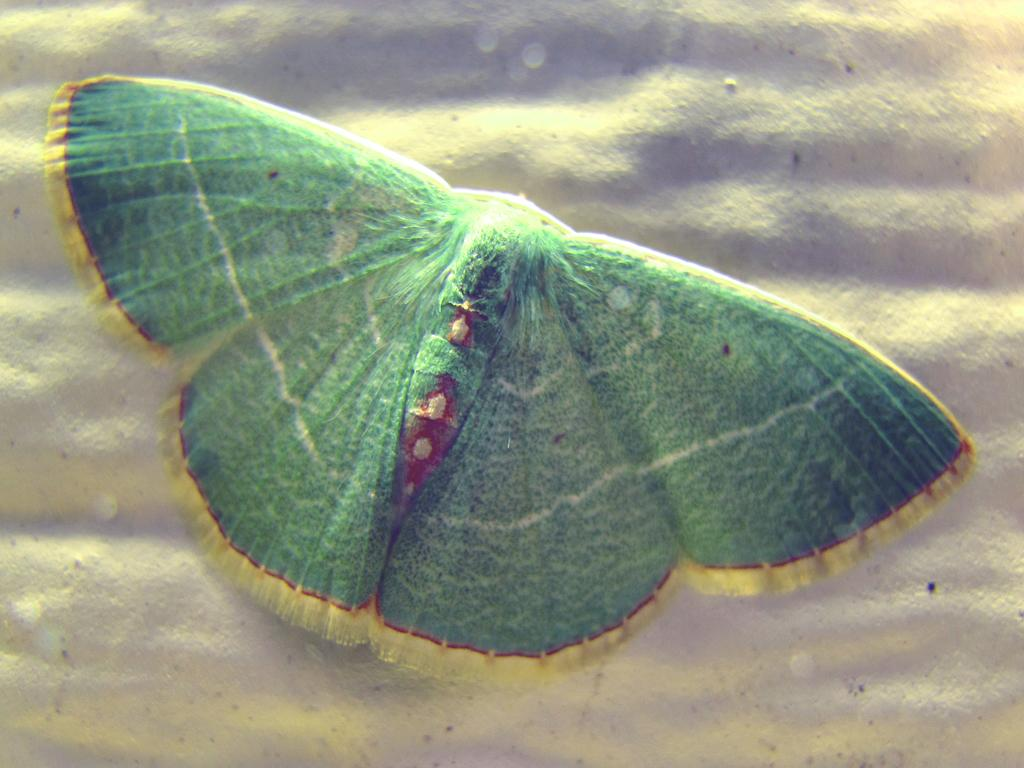What type of creature is present in the image? There is a butterfly in the image. What color is the butterfly? The butterfly is green in color. What type of industry can be seen in the image? There is no industry present in the image; it features a green butterfly. What kind of seed is the butterfly holding in the image? There is no seed present in the image; it features a green butterfly. 